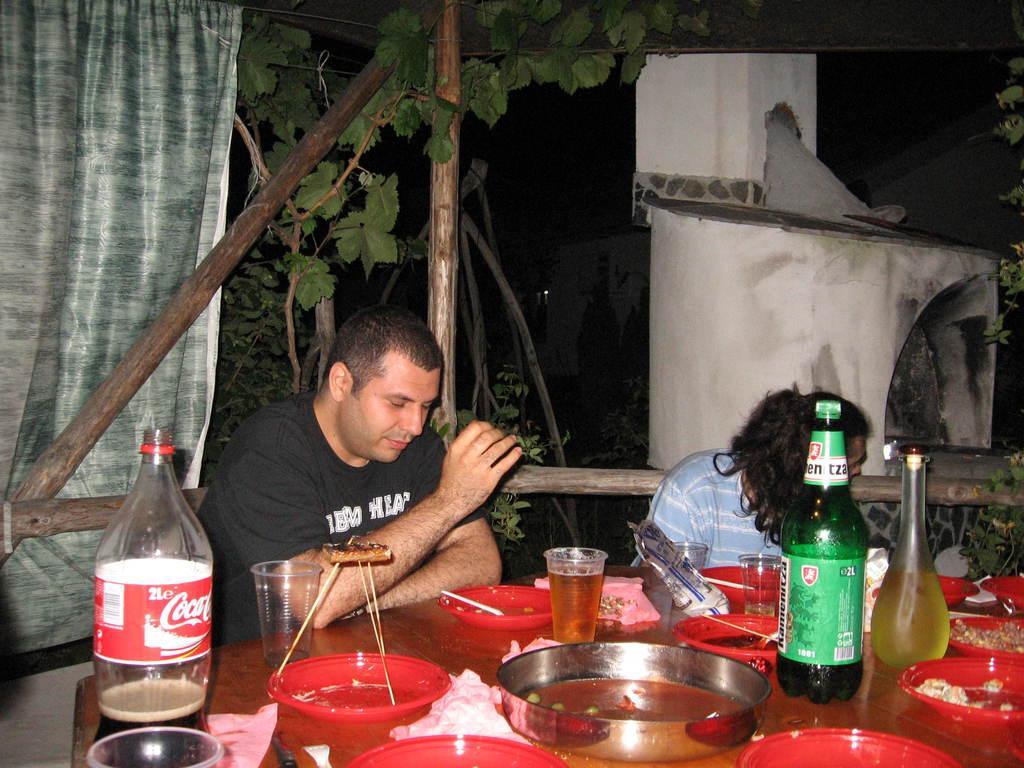Could you give a brief overview of what you see in this image? In the image we can see there are people sitting on the chair and there are plates, bowls, wine glass filled with wine, wine bottle and there is a cold drink bottle kept on the table. There are wooden poles and there is a curtain. 